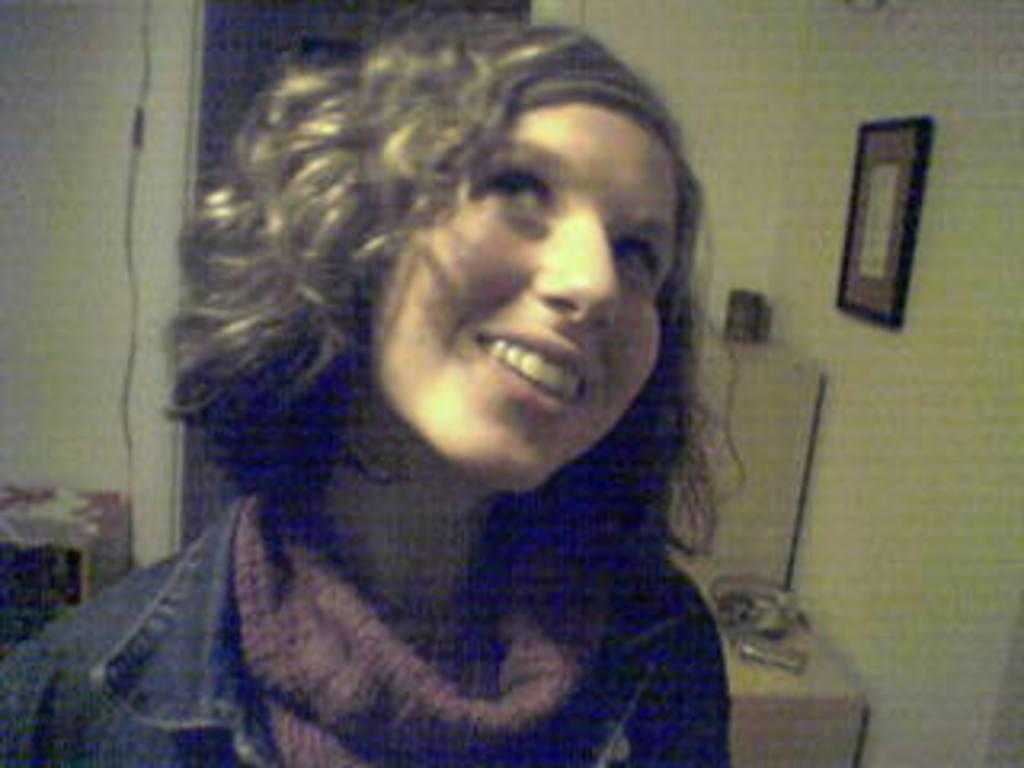Who is present in the image? There is a woman in the image. What is the woman wearing on her upper body? The woman is wearing a jacket and a scarf. What can be seen on the wall in the image? There is a wall with a frame in the image. How many dimes are visible in the frame on the wall? There are no dimes visible in the frame on the wall; the frame is empty in the image. 